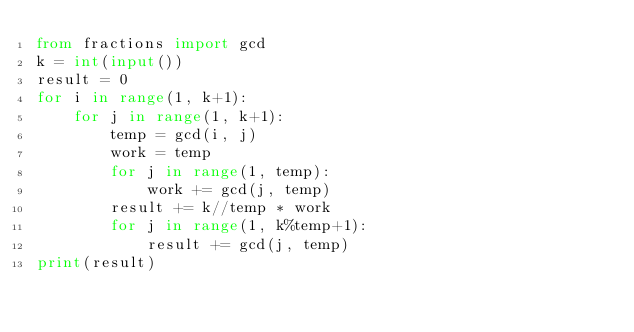<code> <loc_0><loc_0><loc_500><loc_500><_Python_>from fractions import gcd
k = int(input())
result = 0
for i in range(1, k+1):
    for j in range(1, k+1):
        temp = gcd(i, j)
        work = temp
        for j in range(1, temp):
            work += gcd(j, temp)
        result += k//temp * work
        for j in range(1, k%temp+1):
            result += gcd(j, temp)
print(result)</code> 